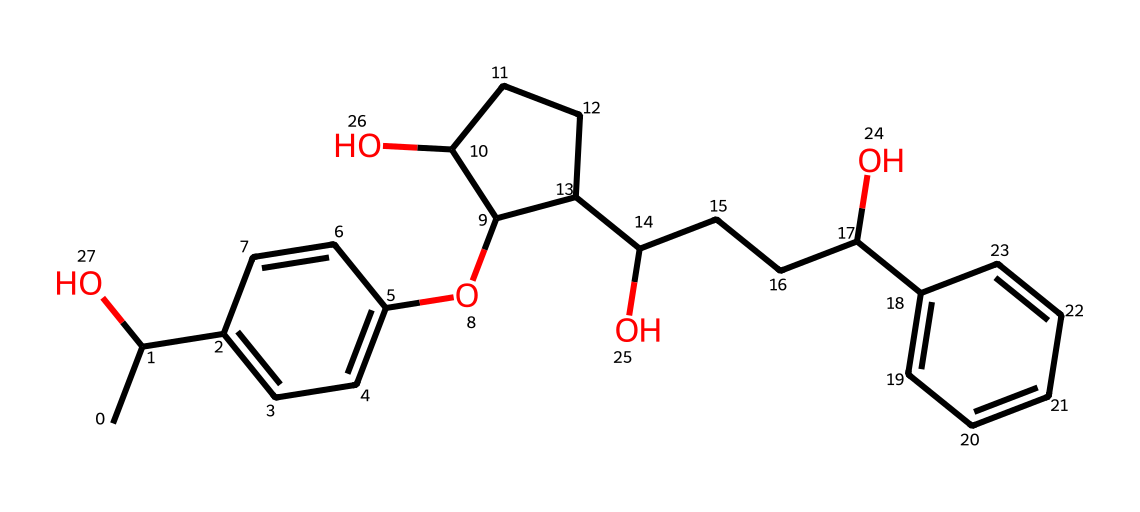What is the molecular formula of this chemical? The molecular formula can be derived by counting the number of each type of atom in the structure. This SMILES representation corresponds to a structure with 21 carbons, 30 hydrogens, and 2 oxygens based on the atoms present in the chain and ring structures.
Answer: C21H30O2 How many rings are present in the structure? To determine the number of rings, observe the structure for any cyclic groups. This SMILES indicates the presence of two ring structures, as indicated by the notation that shows connectivity in circular fashion.
Answer: 2 What type of drug is cannabidiol classified as? Cannabidiol is classified as a cannabinoid, which refers to chemical compounds that interact with cannabinoid receptors in the body. This is understood by recognizing its structural characteristics that are common to cannabinoids.
Answer: cannabinoid Does this chemical contain any hydroxyl groups, and if so, how many? A hydroxyl group (–OH) can be identified in the structure by examining the functional groups present in the molecule. Inspecting the SMILES reveals that there are three –OH groups attached to the carbon skeleton.
Answer: 3 What structural feature is primarily responsible for the psychoactive properties of cannabinoids? The psychoactive properties of cannabinoids are commonly attributed to the presence of the phenolic hydroxyl and the cyclic structures, as these contribute to the interaction with cannabinoid receptors. The presence of specific arrangements of carbon and oxygen gives rise to these properties.
Answer: cyclic structures How many chiral centers does this molecule have? Chiral centers are points in a molecule where the arrangement of atoms leads to non-superimposable mirror images. By analyzing the structural configuration in the SMILES, this molecule contains two chiral centers due to its specific stereochemistry.
Answer: 2 